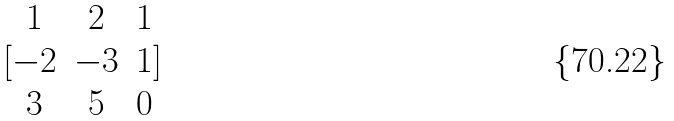Convert formula to latex. <formula><loc_0><loc_0><loc_500><loc_500>[ \begin{matrix} 1 & 2 & 1 \\ - 2 & - 3 & 1 \\ 3 & 5 & 0 \end{matrix} ]</formula> 